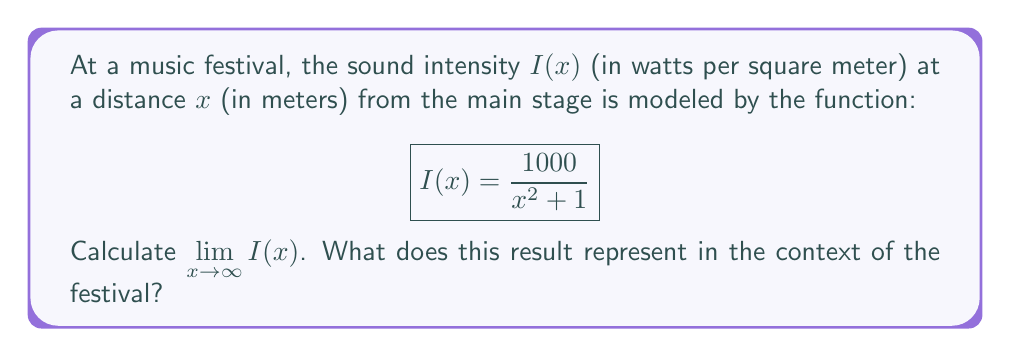Provide a solution to this math problem. To solve this problem, let's follow these steps:

1) We need to evaluate $\lim_{x \to \infty} \frac{1000}{x^2 + 1}$

2) As $x$ approaches infinity, $x^2$ becomes much larger than 1, so we can approximate:

   $$\lim_{x \to \infty} \frac{1000}{x^2 + 1} \approx \lim_{x \to \infty} \frac{1000}{x^2}$$

3) We can factor out $\frac{1}{x^2}$ from the denominator:

   $$\lim_{x \to \infty} \frac{1000}{x^2} = 1000 \cdot \lim_{x \to \infty} \frac{1}{x^2}$$

4) We know that $\lim_{x \to \infty} \frac{1}{x^2} = 0$

5) Therefore:

   $$\lim_{x \to \infty} I(x) = \lim_{x \to \infty} \frac{1000}{x^2 + 1} = 1000 \cdot 0 = 0$$

In the context of the festival, this result represents the sound intensity very far from the stage. As you move infinitely far from the stage, the sound intensity approaches zero, which means you would no longer be able to hear the music.
Answer: $\lim_{x \to \infty} I(x) = 0$ W/m² 